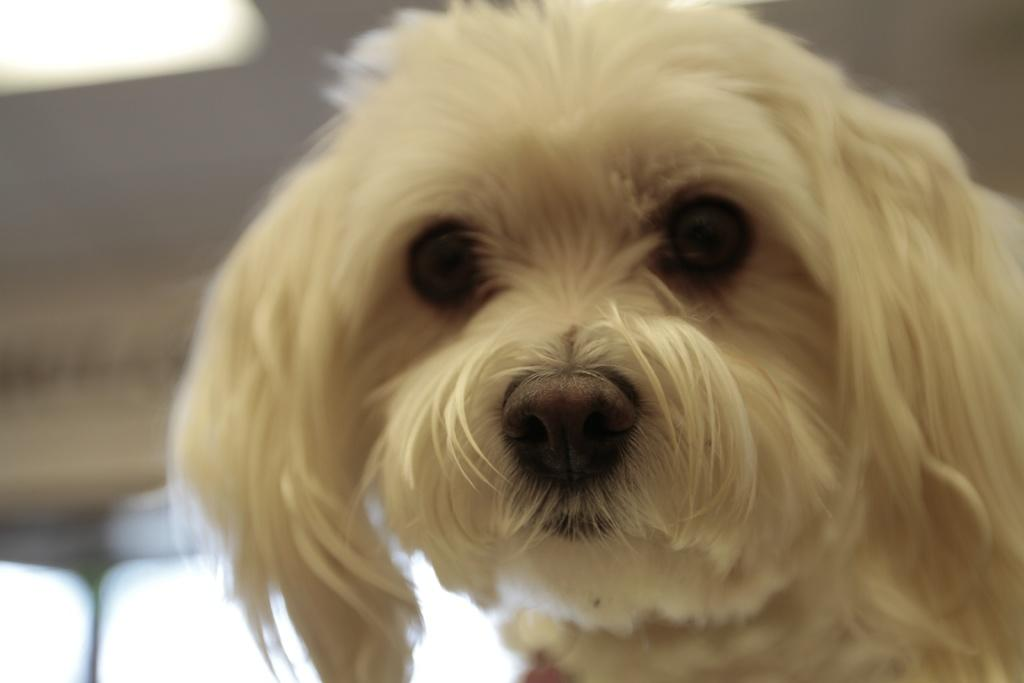What type of animal is in the image? The image contains a dog. What part of the dog can be seen in the image? Only the dog's face is visible in the image. How is the background of the image depicted? The background of the dog is blurred. What type of pail is being used to water the dog in the image? There is no pail or watering activity present in the image; it only shows the dog's face with a blurred background. 